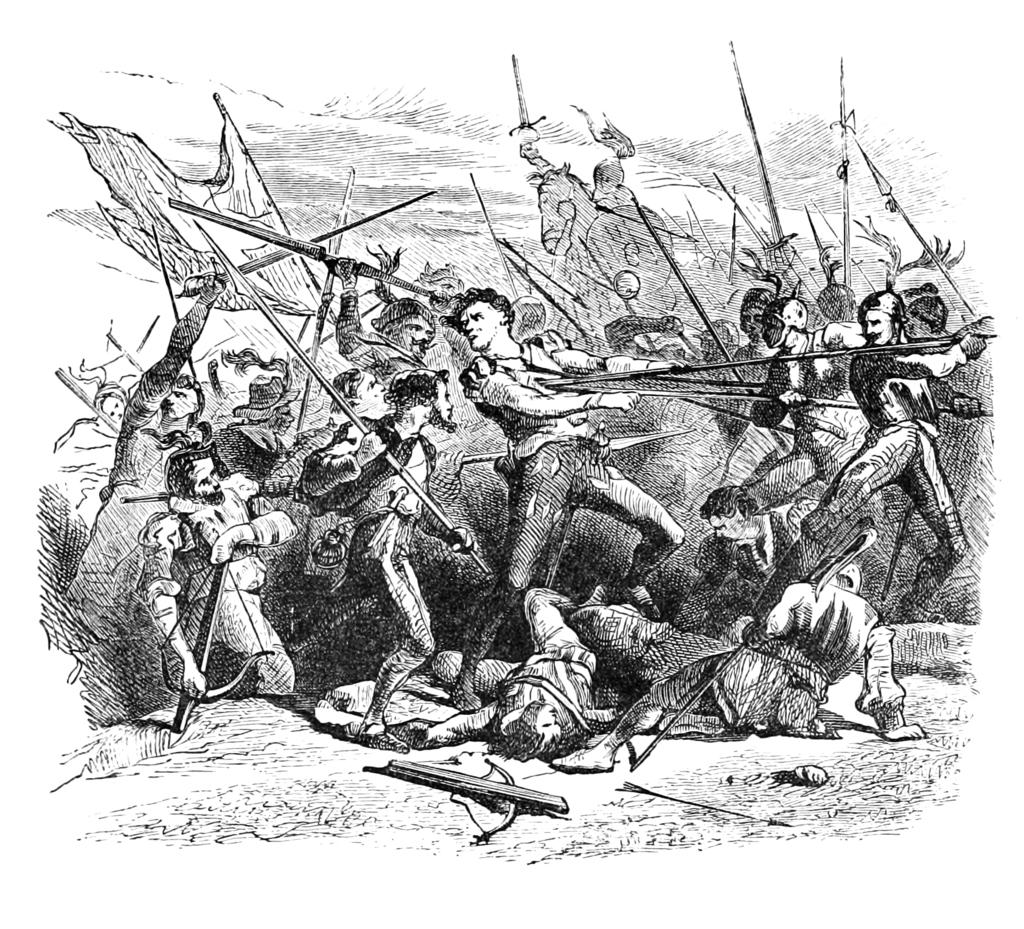What type of image is shown in the picture? The image is a black and white drawing. What is happening in the drawing? The drawing depicts people fighting with each other. How many fish can be seen swimming in the cellar in the image? There are no fish or cellars present in the image; it is a drawing of people fighting with each other. 